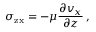<formula> <loc_0><loc_0><loc_500><loc_500>\sigma _ { z x } = - \mu { \frac { \partial v _ { x } } { \partial z } } \, ,</formula> 